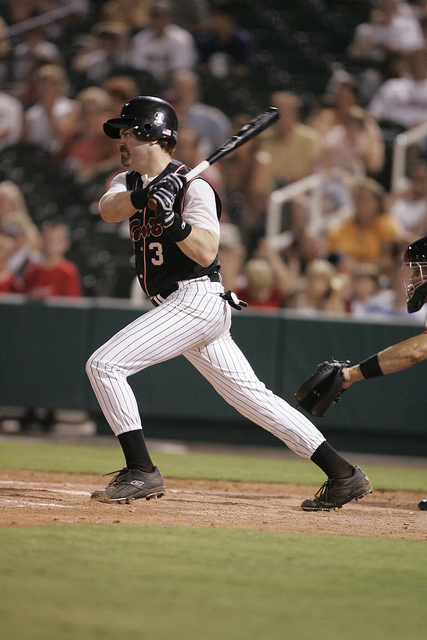Identify the text contained in this image. 3 